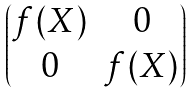<formula> <loc_0><loc_0><loc_500><loc_500>\begin{pmatrix} f ( X ) & 0 \\ 0 & f ( X ) \end{pmatrix}</formula> 